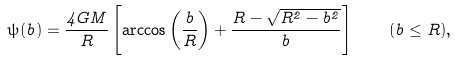Convert formula to latex. <formula><loc_0><loc_0><loc_500><loc_500>\psi ( b ) = \frac { 4 G M } { R } \left [ \arccos \left ( \frac { b } { R } \right ) + \frac { R - \sqrt { R ^ { 2 } - b ^ { 2 } } } { b } \right ] \quad ( b \leq R ) ,</formula> 